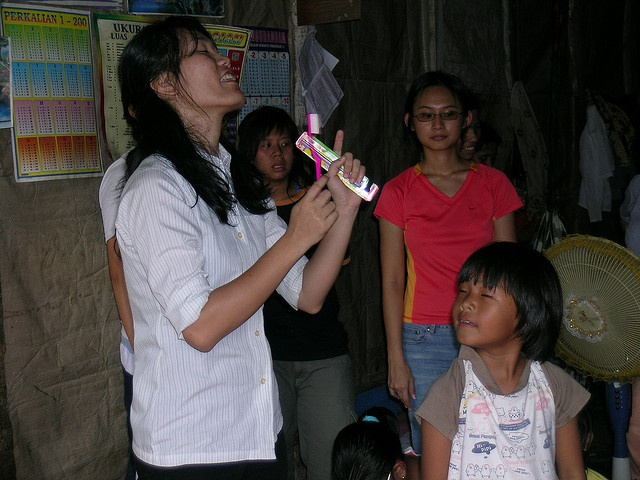Describe the objects in this image and their specific colors. I can see people in black, darkgray, and gray tones, people in black, gray, lightgray, and darkgray tones, people in black, brown, and maroon tones, people in black, maroon, and gray tones, and people in black, maroon, gray, and teal tones in this image. 